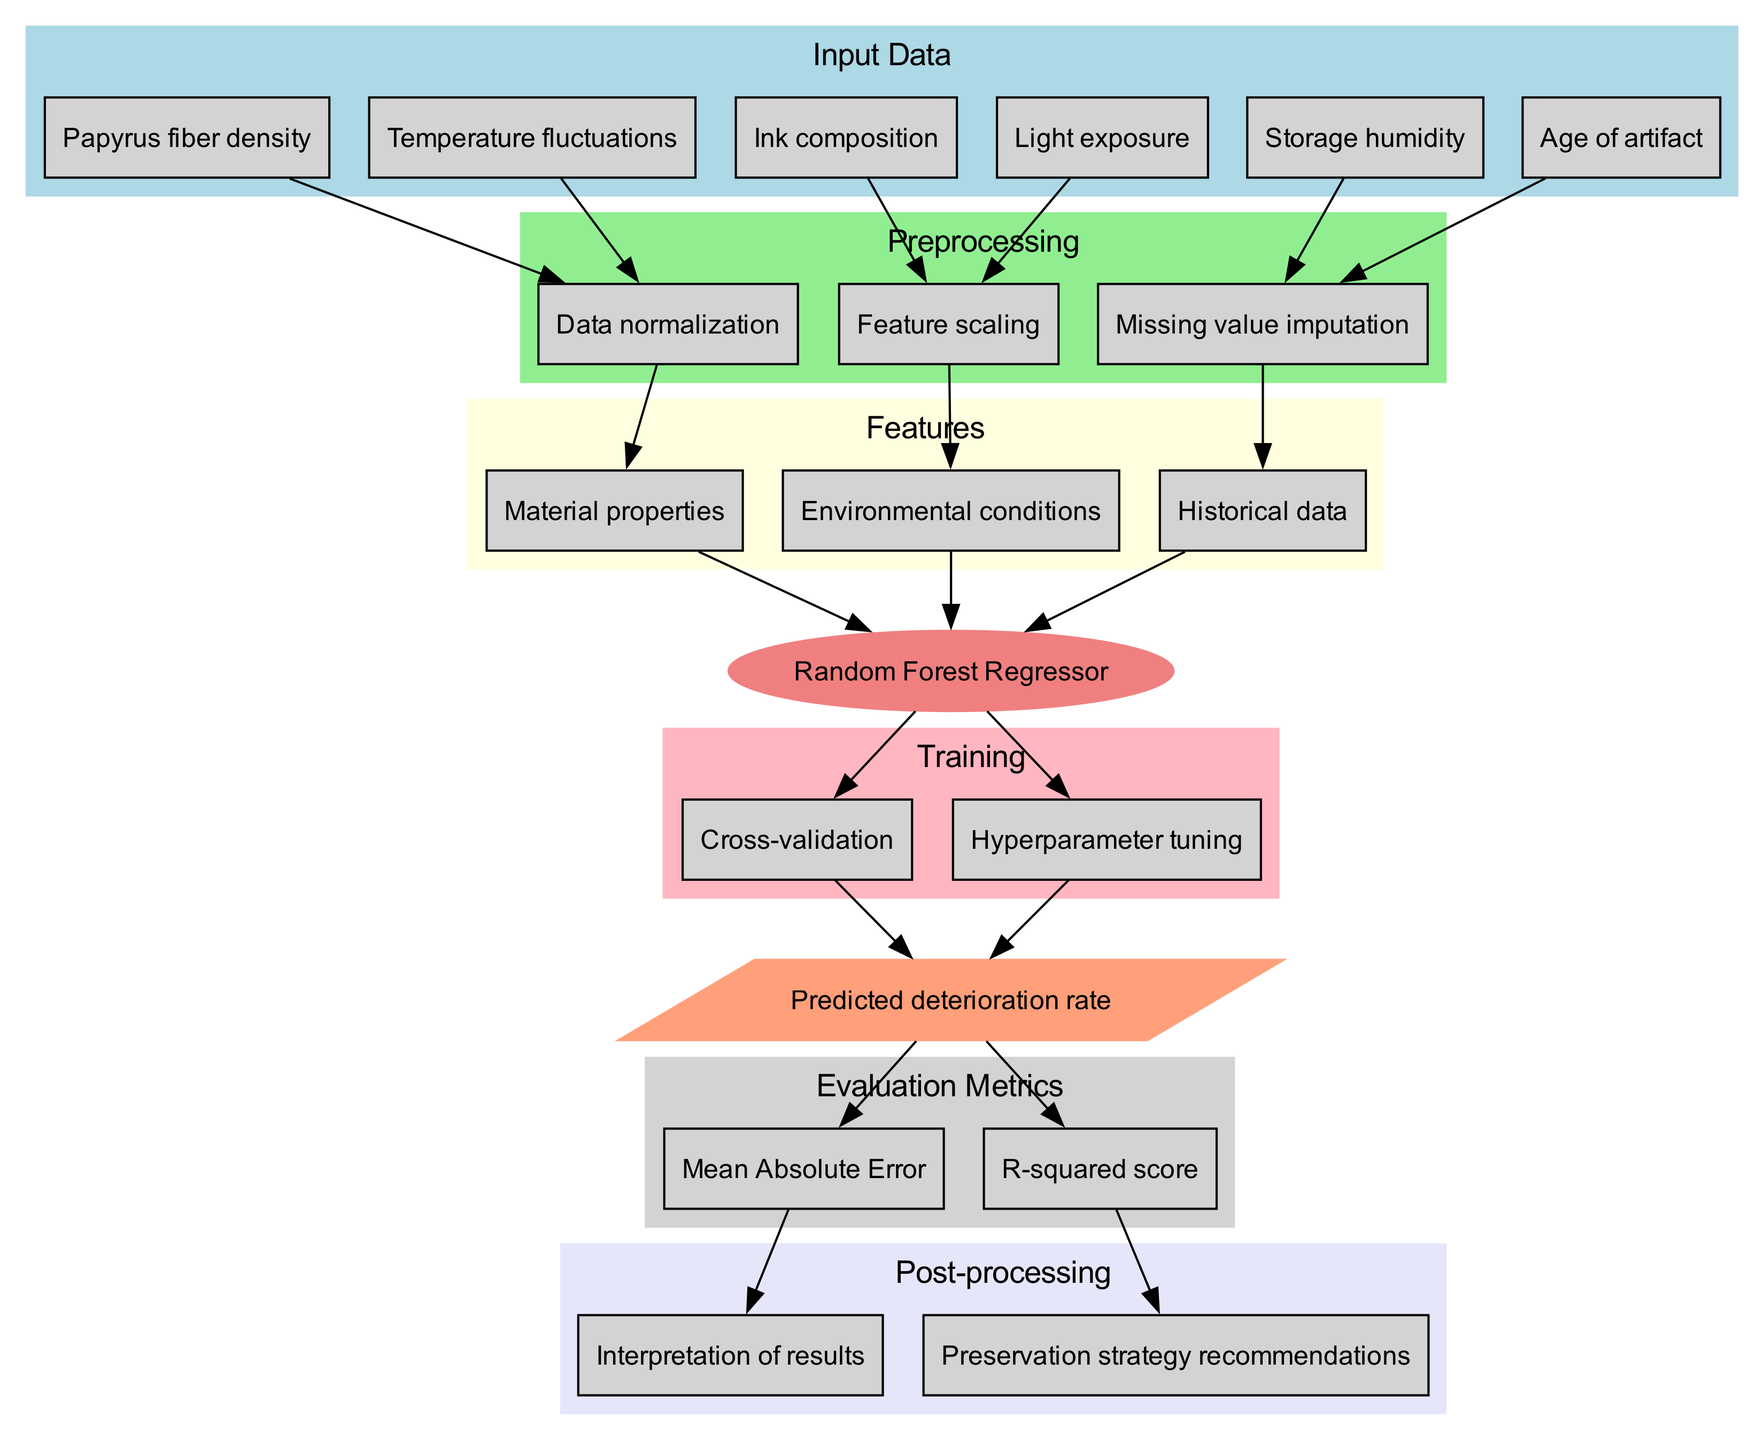What are the input data types in this diagram? The input data types listed in the diagram are Papyrus fiber density, Ink composition, Storage humidity, Temperature fluctuations, Light exposure, and Age of artifact.
Answer: Papyrus fiber density, Ink composition, Storage humidity, Temperature fluctuations, Light exposure, Age of artifact What model is used for predictions in this diagram? The diagram identifies the model used for predictions as a Random Forest Regressor.
Answer: Random Forest Regressor How many preprocessing steps are there? The diagram shows three preprocessing steps: Data normalization, Feature scaling, and Missing value imputation.
Answer: Three What is the first step in the training process? In the diagram, Cross-validation is identified as the first step in the training process.
Answer: Cross-validation What is the output of the model? The model produces a predicted deterioration rate as the output.
Answer: Predicted deterioration rate What evaluation metrics are used to assess the model's performance? The diagram lists Mean Absolute Error and R-squared score as the evaluation metrics for assessing performance.
Answer: Mean Absolute Error, R-squared score Which preprocessing step is directly linked to Light exposure? The diagram shows that Light exposure is linked to the Feature scaling preprocessing step.
Answer: Feature scaling What type of insights are derived from the post-processing phase? The post-processing phase results in two insights: Interpretation of results and Preservation strategy recommendations.
Answer: Interpretation of results, Preservation strategy recommendations How many features are considered for the model? The diagram mentions three features in total: Material properties, Environmental conditions, and Historical data.
Answer: Three 